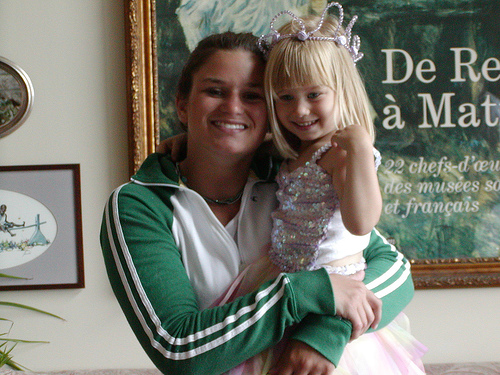<image>
Is there a girl behind the woman? No. The girl is not behind the woman. From this viewpoint, the girl appears to be positioned elsewhere in the scene. Where is the lady in relation to the baby? Is it in the baby? No. The lady is not contained within the baby. These objects have a different spatial relationship. 